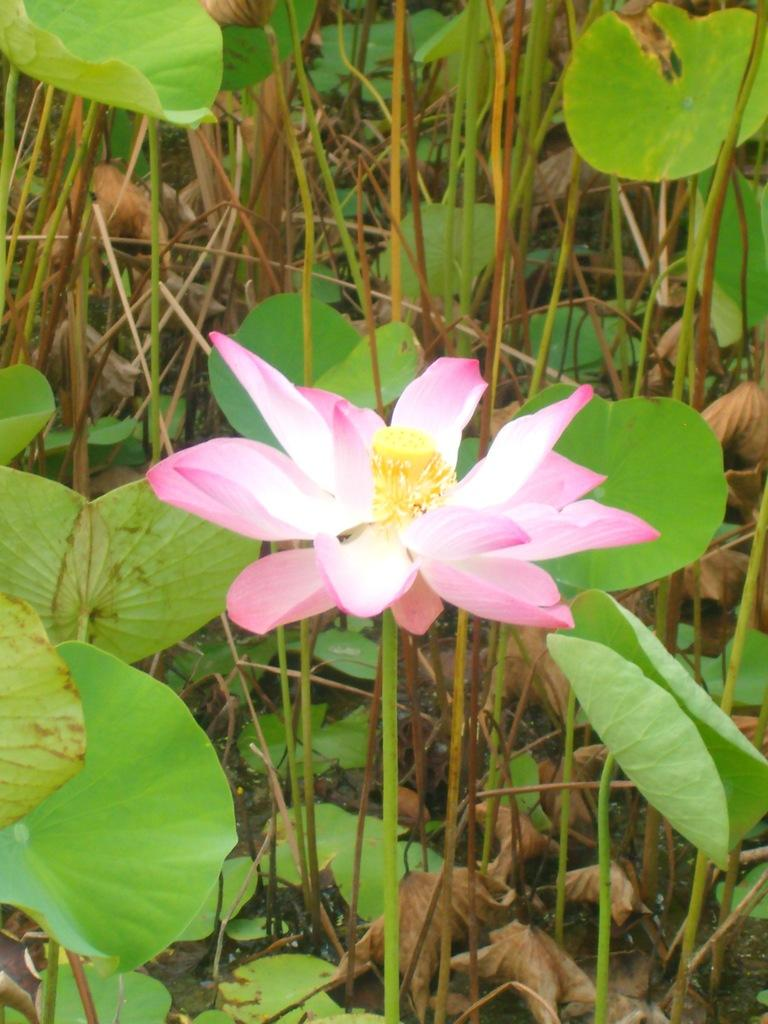What is the main subject of the image? There is a pink flower in the middle of the image. What color are the leaves behind the flower? The leaves behind the flower are green. Can you see a cat wearing jeans in the image? No, there is no cat or jeans present in the image. 